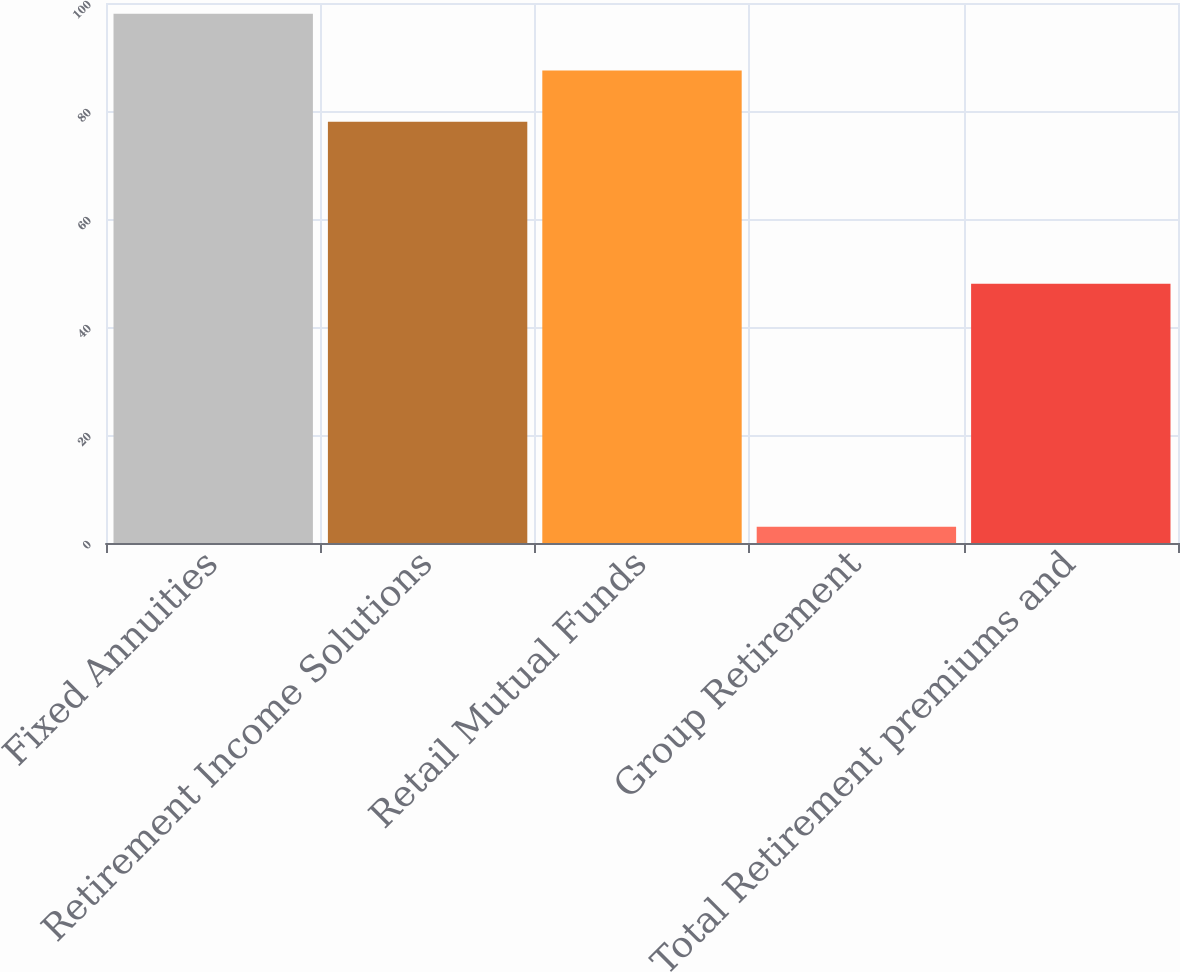Convert chart. <chart><loc_0><loc_0><loc_500><loc_500><bar_chart><fcel>Fixed Annuities<fcel>Retirement Income Solutions<fcel>Retail Mutual Funds<fcel>Group Retirement<fcel>Total Retirement premiums and<nl><fcel>98<fcel>78<fcel>87.5<fcel>3<fcel>48<nl></chart> 